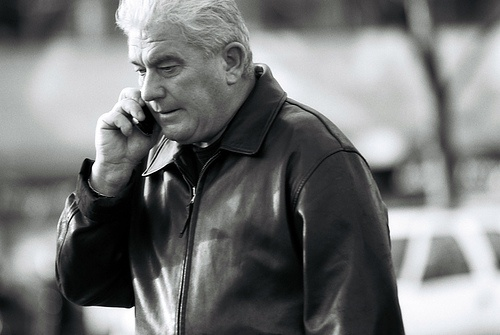Describe the objects in this image and their specific colors. I can see people in black, gray, darkgray, and lightgray tones, car in black, white, darkgray, and gray tones, and cell phone in black, gray, and lightgray tones in this image. 